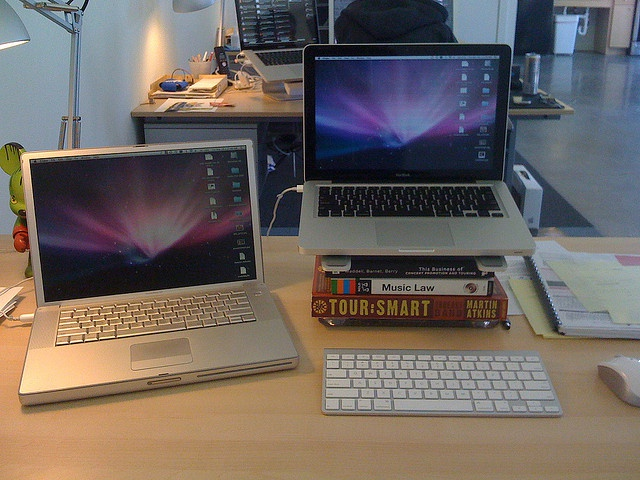Describe the objects in this image and their specific colors. I can see laptop in gray, black, and tan tones, laptop in gray, black, navy, and blue tones, keyboard in gray and tan tones, keyboard in gray and darkgray tones, and laptop in gray, black, and blue tones in this image. 